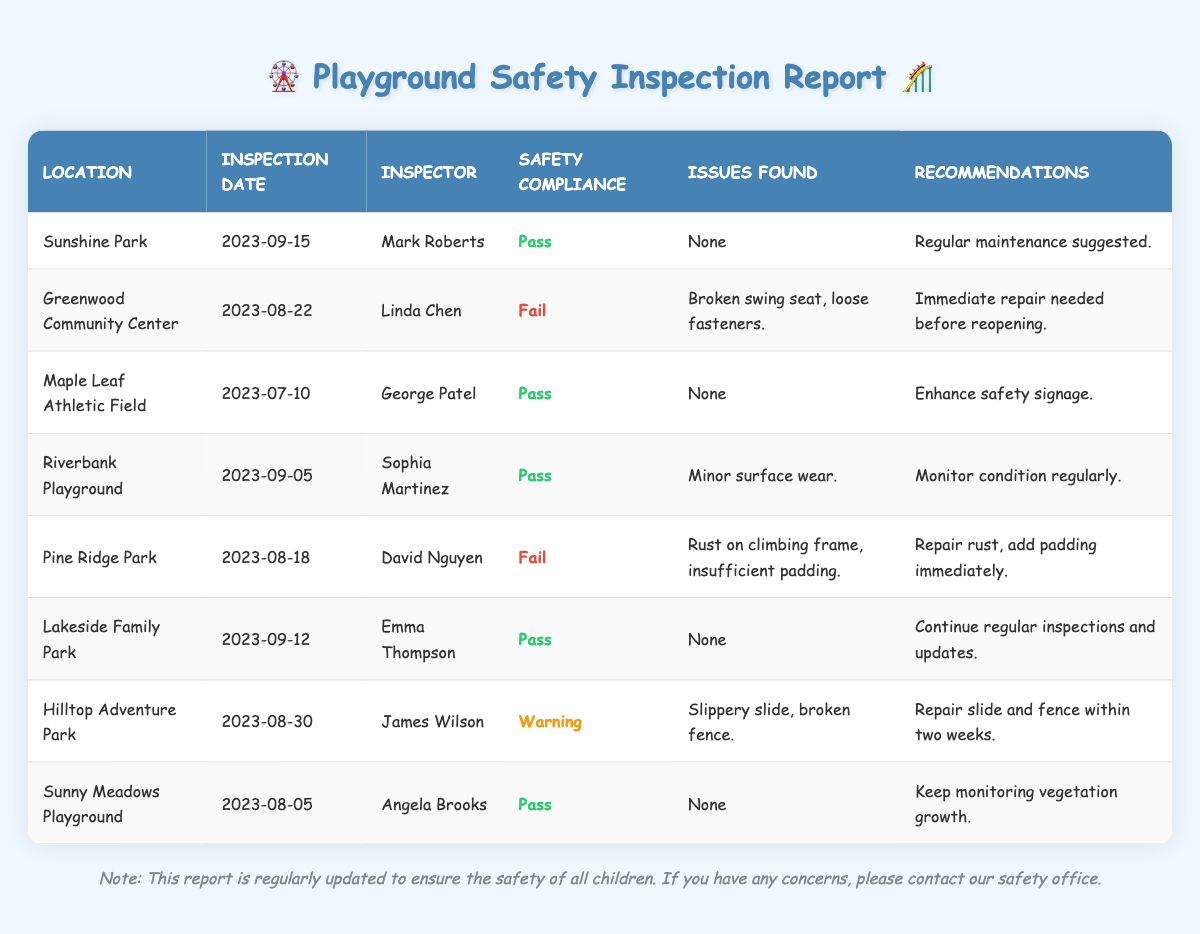What is the safety compliance status of Sunshine Park? The table shows that Sunshine Park has a safety compliance status of "Pass" as noted in the relevant row.
Answer: Pass How many playgrounds have failed their safety inspection? There are two playgrounds listed as "Fail" in the safety compliance column—Greenwood Community Center and Pine Ridge Park.
Answer: 2 What issues were found at Pine Ridge Park? The table states that Pine Ridge Park had issues with "Rust on climbing frame" and "insufficient padding" in the issues found column.
Answer: Rust on climbing frame, insufficient padding Which inspector conducted the inspection at Riverbank Playground? The inspection entry for Riverbank Playground shows that Sophia Martinez was the inspector for that location.
Answer: Sophia Martinez What is the recommendation given for Hilltop Adventure Park? According to the table, the recommendation for Hilltop Adventure Park is to "Repair slide and fence within two weeks."
Answer: Repair slide and fence within two weeks Is there any playground that passed its inspection but had issues found? The table indicates that all playgrounds that passed their inspections (like Lakeside Family Park and Riverbank Playground) reported "None" for issues found. Thus, there is no playground that passed but had issues.
Answer: No What was the earliest inspection date recorded in the table? The earliest inspection date shown in the table is for Maple Leaf Athletic Field, which was inspected on 2023-07-10.
Answer: 2023-07-10 Which playground received a warning instead of a pass or fail? Hilltop Adventure Park is noted as receiving a "Warning" in the safety compliance column, differentiating it from those that passed or failed.
Answer: Hilltop Adventure Park How many playgrounds require immediate action based on inspection results? There are two playgrounds (Greenwood Community Center and Pine Ridge Park) that require immediate action due to their failure status and the specific recommendations given.
Answer: 2 Consider the playgrounds that passed their inspections. What recommendation is most commonly suggested among them? Among the playgrounds that passed, the recommendations are mostly oriented toward maintenance and monitoring, with regular maintenance suggested for Sunshine Park and monitoring for Riverbank Playground. The most common theme is ongoing monitoring.
Answer: Ongoing monitoring 